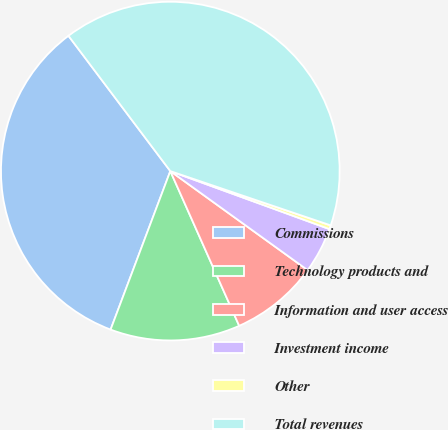Convert chart to OTSL. <chart><loc_0><loc_0><loc_500><loc_500><pie_chart><fcel>Commissions<fcel>Technology products and<fcel>Information and user access<fcel>Investment income<fcel>Other<fcel>Total revenues<nl><fcel>33.99%<fcel>12.4%<fcel>8.39%<fcel>4.38%<fcel>0.37%<fcel>40.46%<nl></chart> 